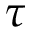<formula> <loc_0><loc_0><loc_500><loc_500>\tau</formula> 